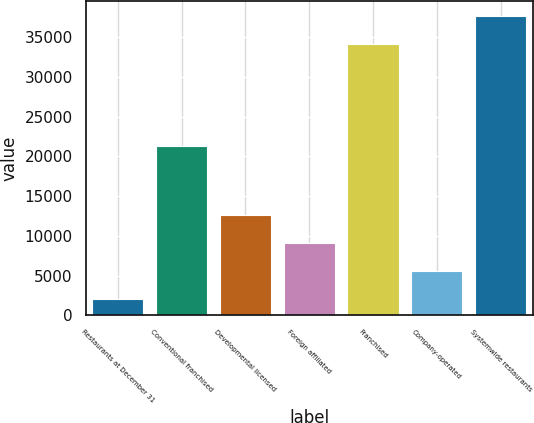Convert chart. <chart><loc_0><loc_0><loc_500><loc_500><bar_chart><fcel>Restaurants at December 31<fcel>Conventional franchised<fcel>Developmental licensed<fcel>Foreign affiliated<fcel>Franchised<fcel>Company-operated<fcel>Systemwide restaurants<nl><fcel>2017<fcel>21366<fcel>12584.2<fcel>9061.8<fcel>34108<fcel>5539.4<fcel>37630.4<nl></chart> 